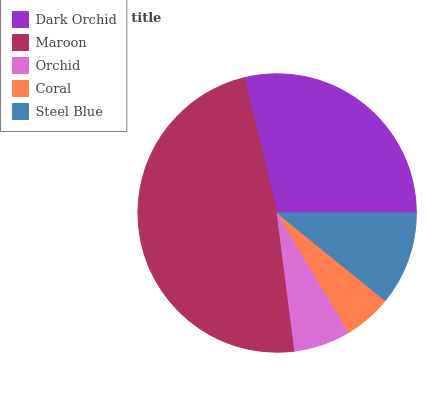Is Coral the minimum?
Answer yes or no. Yes. Is Maroon the maximum?
Answer yes or no. Yes. Is Orchid the minimum?
Answer yes or no. No. Is Orchid the maximum?
Answer yes or no. No. Is Maroon greater than Orchid?
Answer yes or no. Yes. Is Orchid less than Maroon?
Answer yes or no. Yes. Is Orchid greater than Maroon?
Answer yes or no. No. Is Maroon less than Orchid?
Answer yes or no. No. Is Steel Blue the high median?
Answer yes or no. Yes. Is Steel Blue the low median?
Answer yes or no. Yes. Is Maroon the high median?
Answer yes or no. No. Is Coral the low median?
Answer yes or no. No. 